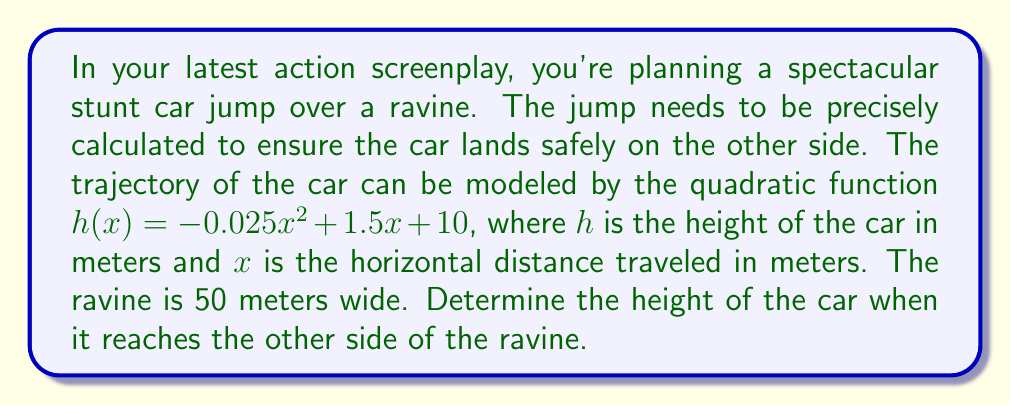Solve this math problem. To solve this problem, we need to follow these steps:

1) The quadratic function given is:
   $h(x) = -0.025x^2 + 1.5x + 10$

2) We need to find the height when the car reaches the other side of the ravine. The ravine is 50 meters wide, so we need to calculate $h(50)$.

3) Let's substitute $x = 50$ into our function:

   $h(50) = -0.025(50)^2 + 1.5(50) + 10$

4) Now let's calculate step by step:
   
   $h(50) = -0.025(2500) + 75 + 10$
   
   $h(50) = -62.5 + 75 + 10$
   
   $h(50) = 22.5$

5) Therefore, when the car reaches the other side of the ravine (50 meters horizontally), it will be at a height of 22.5 meters.

This calculation is crucial for your stunt scene. If the landing area on the other side of the ravine isn't at the right height, you might need to adjust your script or risk a very expensive and dangerous failed stunt!
Answer: The height of the car when it reaches the other side of the ravine (50 meters horizontally) is 22.5 meters. 